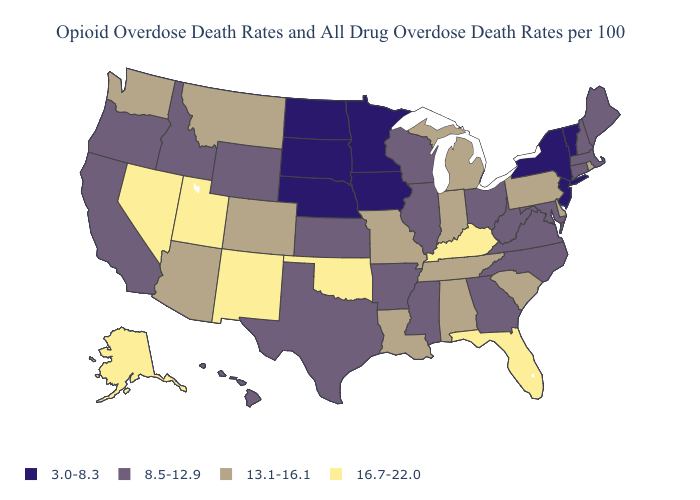What is the value of Minnesota?
Be succinct. 3.0-8.3. Name the states that have a value in the range 13.1-16.1?
Keep it brief. Alabama, Arizona, Colorado, Delaware, Indiana, Louisiana, Michigan, Missouri, Montana, Pennsylvania, Rhode Island, South Carolina, Tennessee, Washington. What is the value of Hawaii?
Answer briefly. 8.5-12.9. How many symbols are there in the legend?
Answer briefly. 4. Does Michigan have the highest value in the MidWest?
Answer briefly. Yes. Name the states that have a value in the range 13.1-16.1?
Be succinct. Alabama, Arizona, Colorado, Delaware, Indiana, Louisiana, Michigan, Missouri, Montana, Pennsylvania, Rhode Island, South Carolina, Tennessee, Washington. What is the value of New Hampshire?
Write a very short answer. 8.5-12.9. What is the lowest value in states that border Pennsylvania?
Answer briefly. 3.0-8.3. Is the legend a continuous bar?
Be succinct. No. Does Washington have the same value as Arkansas?
Concise answer only. No. What is the value of New York?
Answer briefly. 3.0-8.3. Does Colorado have a higher value than Arkansas?
Keep it brief. Yes. Name the states that have a value in the range 16.7-22.0?
Answer briefly. Alaska, Florida, Kentucky, Nevada, New Mexico, Oklahoma, Utah. Which states hav the highest value in the South?
Quick response, please. Florida, Kentucky, Oklahoma. Does Arizona have a lower value than Indiana?
Write a very short answer. No. 